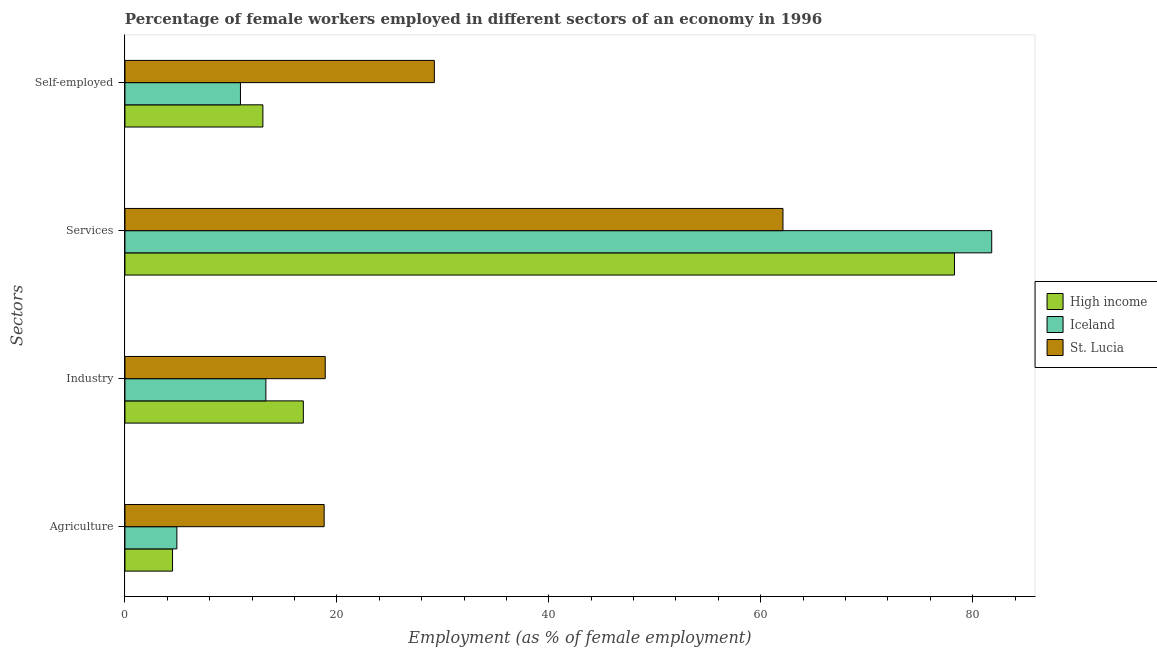How many groups of bars are there?
Offer a terse response. 4. How many bars are there on the 1st tick from the top?
Give a very brief answer. 3. What is the label of the 1st group of bars from the top?
Your response must be concise. Self-employed. What is the percentage of female workers in agriculture in High income?
Provide a succinct answer. 4.49. Across all countries, what is the maximum percentage of self employed female workers?
Make the answer very short. 29.2. Across all countries, what is the minimum percentage of female workers in agriculture?
Offer a terse response. 4.49. In which country was the percentage of female workers in industry maximum?
Provide a short and direct response. St. Lucia. What is the total percentage of female workers in services in the graph?
Your answer should be compact. 222.18. What is the difference between the percentage of female workers in agriculture in Iceland and that in St. Lucia?
Your answer should be very brief. -13.9. What is the difference between the percentage of female workers in agriculture in High income and the percentage of female workers in industry in Iceland?
Ensure brevity in your answer.  -8.81. What is the average percentage of female workers in agriculture per country?
Keep it short and to the point. 9.4. What is the difference between the percentage of self employed female workers and percentage of female workers in industry in High income?
Provide a short and direct response. -3.82. What is the ratio of the percentage of female workers in agriculture in High income to that in St. Lucia?
Provide a short and direct response. 0.24. What is the difference between the highest and the second highest percentage of female workers in industry?
Give a very brief answer. 2.06. What is the difference between the highest and the lowest percentage of female workers in services?
Keep it short and to the point. 19.7. Is it the case that in every country, the sum of the percentage of female workers in industry and percentage of female workers in services is greater than the sum of percentage of female workers in agriculture and percentage of self employed female workers?
Offer a terse response. Yes. Is it the case that in every country, the sum of the percentage of female workers in agriculture and percentage of female workers in industry is greater than the percentage of female workers in services?
Provide a succinct answer. No. How many bars are there?
Your answer should be very brief. 12. Are all the bars in the graph horizontal?
Ensure brevity in your answer.  Yes. Are the values on the major ticks of X-axis written in scientific E-notation?
Your answer should be very brief. No. Does the graph contain any zero values?
Offer a very short reply. No. Does the graph contain grids?
Give a very brief answer. No. How are the legend labels stacked?
Provide a succinct answer. Vertical. What is the title of the graph?
Give a very brief answer. Percentage of female workers employed in different sectors of an economy in 1996. What is the label or title of the X-axis?
Make the answer very short. Employment (as % of female employment). What is the label or title of the Y-axis?
Your answer should be compact. Sectors. What is the Employment (as % of female employment) in High income in Agriculture?
Ensure brevity in your answer.  4.49. What is the Employment (as % of female employment) in Iceland in Agriculture?
Your answer should be very brief. 4.9. What is the Employment (as % of female employment) of St. Lucia in Agriculture?
Make the answer very short. 18.8. What is the Employment (as % of female employment) in High income in Industry?
Make the answer very short. 16.84. What is the Employment (as % of female employment) of Iceland in Industry?
Your response must be concise. 13.3. What is the Employment (as % of female employment) in St. Lucia in Industry?
Provide a short and direct response. 18.9. What is the Employment (as % of female employment) of High income in Services?
Keep it short and to the point. 78.28. What is the Employment (as % of female employment) in Iceland in Services?
Ensure brevity in your answer.  81.8. What is the Employment (as % of female employment) of St. Lucia in Services?
Make the answer very short. 62.1. What is the Employment (as % of female employment) of High income in Self-employed?
Make the answer very short. 13.02. What is the Employment (as % of female employment) in Iceland in Self-employed?
Your answer should be compact. 10.9. What is the Employment (as % of female employment) of St. Lucia in Self-employed?
Your answer should be very brief. 29.2. Across all Sectors, what is the maximum Employment (as % of female employment) in High income?
Your response must be concise. 78.28. Across all Sectors, what is the maximum Employment (as % of female employment) in Iceland?
Your answer should be very brief. 81.8. Across all Sectors, what is the maximum Employment (as % of female employment) in St. Lucia?
Ensure brevity in your answer.  62.1. Across all Sectors, what is the minimum Employment (as % of female employment) of High income?
Ensure brevity in your answer.  4.49. Across all Sectors, what is the minimum Employment (as % of female employment) in Iceland?
Provide a succinct answer. 4.9. Across all Sectors, what is the minimum Employment (as % of female employment) in St. Lucia?
Give a very brief answer. 18.8. What is the total Employment (as % of female employment) in High income in the graph?
Your response must be concise. 112.63. What is the total Employment (as % of female employment) of Iceland in the graph?
Offer a very short reply. 110.9. What is the total Employment (as % of female employment) of St. Lucia in the graph?
Offer a very short reply. 129. What is the difference between the Employment (as % of female employment) in High income in Agriculture and that in Industry?
Keep it short and to the point. -12.34. What is the difference between the Employment (as % of female employment) of Iceland in Agriculture and that in Industry?
Provide a short and direct response. -8.4. What is the difference between the Employment (as % of female employment) of High income in Agriculture and that in Services?
Provide a short and direct response. -73.79. What is the difference between the Employment (as % of female employment) in Iceland in Agriculture and that in Services?
Give a very brief answer. -76.9. What is the difference between the Employment (as % of female employment) of St. Lucia in Agriculture and that in Services?
Make the answer very short. -43.3. What is the difference between the Employment (as % of female employment) of High income in Agriculture and that in Self-employed?
Provide a short and direct response. -8.53. What is the difference between the Employment (as % of female employment) of St. Lucia in Agriculture and that in Self-employed?
Make the answer very short. -10.4. What is the difference between the Employment (as % of female employment) of High income in Industry and that in Services?
Make the answer very short. -61.45. What is the difference between the Employment (as % of female employment) in Iceland in Industry and that in Services?
Provide a succinct answer. -68.5. What is the difference between the Employment (as % of female employment) of St. Lucia in Industry and that in Services?
Your answer should be compact. -43.2. What is the difference between the Employment (as % of female employment) in High income in Industry and that in Self-employed?
Provide a succinct answer. 3.82. What is the difference between the Employment (as % of female employment) of Iceland in Industry and that in Self-employed?
Provide a succinct answer. 2.4. What is the difference between the Employment (as % of female employment) in St. Lucia in Industry and that in Self-employed?
Your answer should be very brief. -10.3. What is the difference between the Employment (as % of female employment) in High income in Services and that in Self-employed?
Your answer should be compact. 65.27. What is the difference between the Employment (as % of female employment) in Iceland in Services and that in Self-employed?
Give a very brief answer. 70.9. What is the difference between the Employment (as % of female employment) in St. Lucia in Services and that in Self-employed?
Your answer should be very brief. 32.9. What is the difference between the Employment (as % of female employment) in High income in Agriculture and the Employment (as % of female employment) in Iceland in Industry?
Give a very brief answer. -8.81. What is the difference between the Employment (as % of female employment) in High income in Agriculture and the Employment (as % of female employment) in St. Lucia in Industry?
Offer a terse response. -14.41. What is the difference between the Employment (as % of female employment) of High income in Agriculture and the Employment (as % of female employment) of Iceland in Services?
Give a very brief answer. -77.31. What is the difference between the Employment (as % of female employment) of High income in Agriculture and the Employment (as % of female employment) of St. Lucia in Services?
Your answer should be compact. -57.61. What is the difference between the Employment (as % of female employment) of Iceland in Agriculture and the Employment (as % of female employment) of St. Lucia in Services?
Provide a succinct answer. -57.2. What is the difference between the Employment (as % of female employment) of High income in Agriculture and the Employment (as % of female employment) of Iceland in Self-employed?
Offer a very short reply. -6.41. What is the difference between the Employment (as % of female employment) of High income in Agriculture and the Employment (as % of female employment) of St. Lucia in Self-employed?
Your answer should be compact. -24.71. What is the difference between the Employment (as % of female employment) of Iceland in Agriculture and the Employment (as % of female employment) of St. Lucia in Self-employed?
Make the answer very short. -24.3. What is the difference between the Employment (as % of female employment) in High income in Industry and the Employment (as % of female employment) in Iceland in Services?
Provide a short and direct response. -64.97. What is the difference between the Employment (as % of female employment) in High income in Industry and the Employment (as % of female employment) in St. Lucia in Services?
Provide a succinct answer. -45.27. What is the difference between the Employment (as % of female employment) in Iceland in Industry and the Employment (as % of female employment) in St. Lucia in Services?
Ensure brevity in your answer.  -48.8. What is the difference between the Employment (as % of female employment) of High income in Industry and the Employment (as % of female employment) of Iceland in Self-employed?
Ensure brevity in your answer.  5.93. What is the difference between the Employment (as % of female employment) of High income in Industry and the Employment (as % of female employment) of St. Lucia in Self-employed?
Give a very brief answer. -12.37. What is the difference between the Employment (as % of female employment) in Iceland in Industry and the Employment (as % of female employment) in St. Lucia in Self-employed?
Your response must be concise. -15.9. What is the difference between the Employment (as % of female employment) in High income in Services and the Employment (as % of female employment) in Iceland in Self-employed?
Keep it short and to the point. 67.38. What is the difference between the Employment (as % of female employment) in High income in Services and the Employment (as % of female employment) in St. Lucia in Self-employed?
Make the answer very short. 49.08. What is the difference between the Employment (as % of female employment) of Iceland in Services and the Employment (as % of female employment) of St. Lucia in Self-employed?
Provide a short and direct response. 52.6. What is the average Employment (as % of female employment) in High income per Sectors?
Your response must be concise. 28.16. What is the average Employment (as % of female employment) of Iceland per Sectors?
Ensure brevity in your answer.  27.73. What is the average Employment (as % of female employment) in St. Lucia per Sectors?
Provide a short and direct response. 32.25. What is the difference between the Employment (as % of female employment) of High income and Employment (as % of female employment) of Iceland in Agriculture?
Make the answer very short. -0.41. What is the difference between the Employment (as % of female employment) of High income and Employment (as % of female employment) of St. Lucia in Agriculture?
Provide a succinct answer. -14.31. What is the difference between the Employment (as % of female employment) in High income and Employment (as % of female employment) in Iceland in Industry?
Your answer should be compact. 3.54. What is the difference between the Employment (as % of female employment) in High income and Employment (as % of female employment) in St. Lucia in Industry?
Provide a short and direct response. -2.06. What is the difference between the Employment (as % of female employment) in Iceland and Employment (as % of female employment) in St. Lucia in Industry?
Offer a very short reply. -5.6. What is the difference between the Employment (as % of female employment) of High income and Employment (as % of female employment) of Iceland in Services?
Make the answer very short. -3.52. What is the difference between the Employment (as % of female employment) of High income and Employment (as % of female employment) of St. Lucia in Services?
Offer a terse response. 16.18. What is the difference between the Employment (as % of female employment) of Iceland and Employment (as % of female employment) of St. Lucia in Services?
Your answer should be very brief. 19.7. What is the difference between the Employment (as % of female employment) of High income and Employment (as % of female employment) of Iceland in Self-employed?
Keep it short and to the point. 2.12. What is the difference between the Employment (as % of female employment) in High income and Employment (as % of female employment) in St. Lucia in Self-employed?
Make the answer very short. -16.18. What is the difference between the Employment (as % of female employment) in Iceland and Employment (as % of female employment) in St. Lucia in Self-employed?
Give a very brief answer. -18.3. What is the ratio of the Employment (as % of female employment) of High income in Agriculture to that in Industry?
Offer a very short reply. 0.27. What is the ratio of the Employment (as % of female employment) in Iceland in Agriculture to that in Industry?
Make the answer very short. 0.37. What is the ratio of the Employment (as % of female employment) in St. Lucia in Agriculture to that in Industry?
Make the answer very short. 0.99. What is the ratio of the Employment (as % of female employment) in High income in Agriculture to that in Services?
Keep it short and to the point. 0.06. What is the ratio of the Employment (as % of female employment) in Iceland in Agriculture to that in Services?
Keep it short and to the point. 0.06. What is the ratio of the Employment (as % of female employment) in St. Lucia in Agriculture to that in Services?
Your answer should be compact. 0.3. What is the ratio of the Employment (as % of female employment) in High income in Agriculture to that in Self-employed?
Make the answer very short. 0.35. What is the ratio of the Employment (as % of female employment) in Iceland in Agriculture to that in Self-employed?
Give a very brief answer. 0.45. What is the ratio of the Employment (as % of female employment) of St. Lucia in Agriculture to that in Self-employed?
Your answer should be compact. 0.64. What is the ratio of the Employment (as % of female employment) in High income in Industry to that in Services?
Ensure brevity in your answer.  0.22. What is the ratio of the Employment (as % of female employment) of Iceland in Industry to that in Services?
Offer a very short reply. 0.16. What is the ratio of the Employment (as % of female employment) in St. Lucia in Industry to that in Services?
Keep it short and to the point. 0.3. What is the ratio of the Employment (as % of female employment) of High income in Industry to that in Self-employed?
Your response must be concise. 1.29. What is the ratio of the Employment (as % of female employment) of Iceland in Industry to that in Self-employed?
Give a very brief answer. 1.22. What is the ratio of the Employment (as % of female employment) in St. Lucia in Industry to that in Self-employed?
Keep it short and to the point. 0.65. What is the ratio of the Employment (as % of female employment) of High income in Services to that in Self-employed?
Make the answer very short. 6.01. What is the ratio of the Employment (as % of female employment) of Iceland in Services to that in Self-employed?
Provide a short and direct response. 7.5. What is the ratio of the Employment (as % of female employment) of St. Lucia in Services to that in Self-employed?
Your response must be concise. 2.13. What is the difference between the highest and the second highest Employment (as % of female employment) of High income?
Your answer should be compact. 61.45. What is the difference between the highest and the second highest Employment (as % of female employment) of Iceland?
Offer a terse response. 68.5. What is the difference between the highest and the second highest Employment (as % of female employment) in St. Lucia?
Offer a very short reply. 32.9. What is the difference between the highest and the lowest Employment (as % of female employment) of High income?
Your answer should be compact. 73.79. What is the difference between the highest and the lowest Employment (as % of female employment) of Iceland?
Keep it short and to the point. 76.9. What is the difference between the highest and the lowest Employment (as % of female employment) in St. Lucia?
Offer a very short reply. 43.3. 